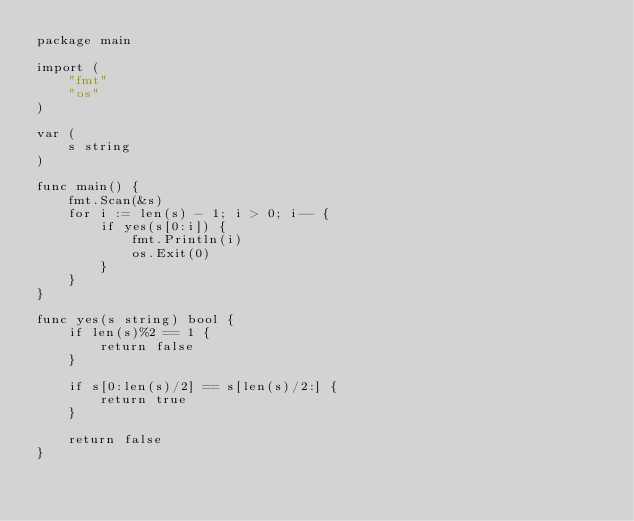<code> <loc_0><loc_0><loc_500><loc_500><_Go_>package main

import (
	"fmt"
	"os"
)

var (
	s string
)

func main() {
	fmt.Scan(&s)
	for i := len(s) - 1; i > 0; i-- {
		if yes(s[0:i]) {
			fmt.Println(i)
			os.Exit(0)
		}
	}
}

func yes(s string) bool {
	if len(s)%2 == 1 {
		return false
	}

	if s[0:len(s)/2] == s[len(s)/2:] {
		return true
	}

	return false
}</code> 